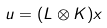Convert formula to latex. <formula><loc_0><loc_0><loc_500><loc_500>u = ( L \otimes K ) x</formula> 